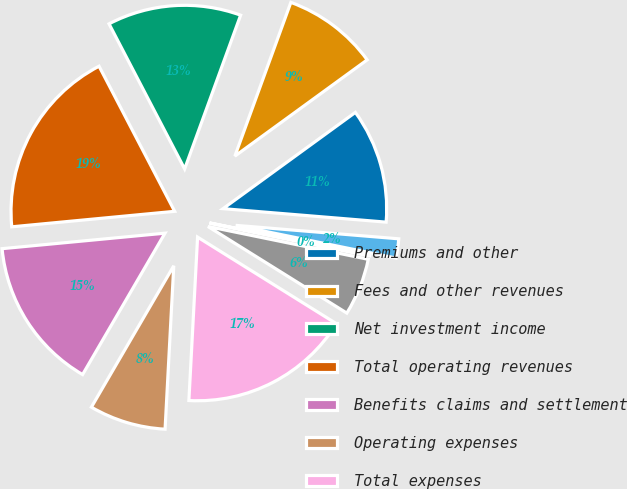Convert chart. <chart><loc_0><loc_0><loc_500><loc_500><pie_chart><fcel>Premiums and other<fcel>Fees and other revenues<fcel>Net investment income<fcel>Total operating revenues<fcel>Benefits claims and settlement<fcel>Operating expenses<fcel>Total expenses<fcel>Operating earnings before<fcel>Income taxes (benefits)<fcel>Operating earnings (losses)<nl><fcel>11.32%<fcel>9.43%<fcel>13.2%<fcel>18.86%<fcel>15.09%<fcel>7.55%<fcel>16.97%<fcel>5.66%<fcel>0.01%<fcel>1.89%<nl></chart> 